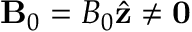Convert formula to latex. <formula><loc_0><loc_0><loc_500><loc_500>B _ { 0 } = B _ { 0 } \hat { z } \neq 0</formula> 